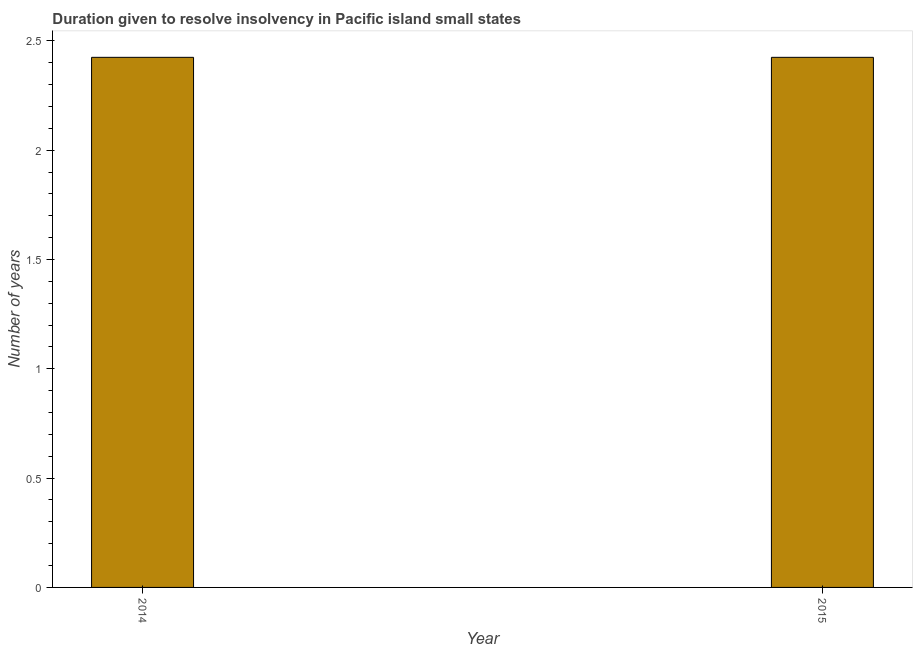Does the graph contain any zero values?
Offer a terse response. No. Does the graph contain grids?
Provide a short and direct response. No. What is the title of the graph?
Your response must be concise. Duration given to resolve insolvency in Pacific island small states. What is the label or title of the Y-axis?
Offer a terse response. Number of years. What is the number of years to resolve insolvency in 2015?
Offer a terse response. 2.42. Across all years, what is the maximum number of years to resolve insolvency?
Your answer should be compact. 2.42. Across all years, what is the minimum number of years to resolve insolvency?
Provide a short and direct response. 2.42. What is the sum of the number of years to resolve insolvency?
Offer a very short reply. 4.85. What is the difference between the number of years to resolve insolvency in 2014 and 2015?
Make the answer very short. 0. What is the average number of years to resolve insolvency per year?
Your response must be concise. 2.42. What is the median number of years to resolve insolvency?
Ensure brevity in your answer.  2.42. What is the ratio of the number of years to resolve insolvency in 2014 to that in 2015?
Your response must be concise. 1. Is the number of years to resolve insolvency in 2014 less than that in 2015?
Ensure brevity in your answer.  No. How many bars are there?
Keep it short and to the point. 2. Are all the bars in the graph horizontal?
Your response must be concise. No. How many years are there in the graph?
Give a very brief answer. 2. What is the Number of years in 2014?
Make the answer very short. 2.42. What is the Number of years in 2015?
Your answer should be compact. 2.42. What is the difference between the Number of years in 2014 and 2015?
Ensure brevity in your answer.  0. What is the ratio of the Number of years in 2014 to that in 2015?
Keep it short and to the point. 1. 